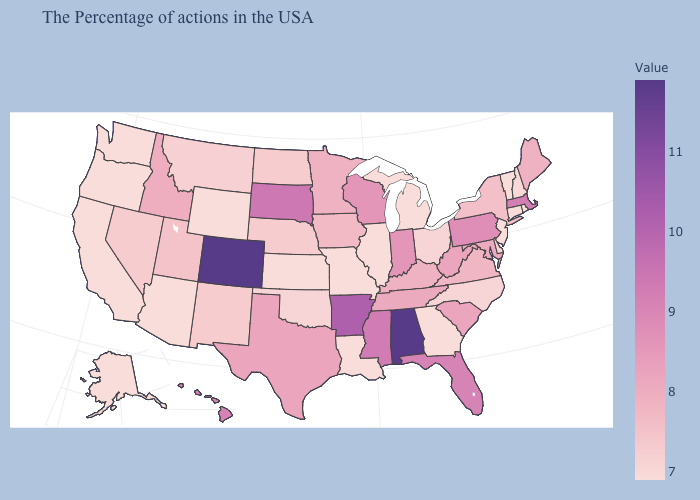Among the states that border Ohio , does Michigan have the lowest value?
Answer briefly. Yes. Among the states that border South Carolina , does Georgia have the highest value?
Give a very brief answer. No. Which states hav the highest value in the MidWest?
Keep it brief. South Dakota. 